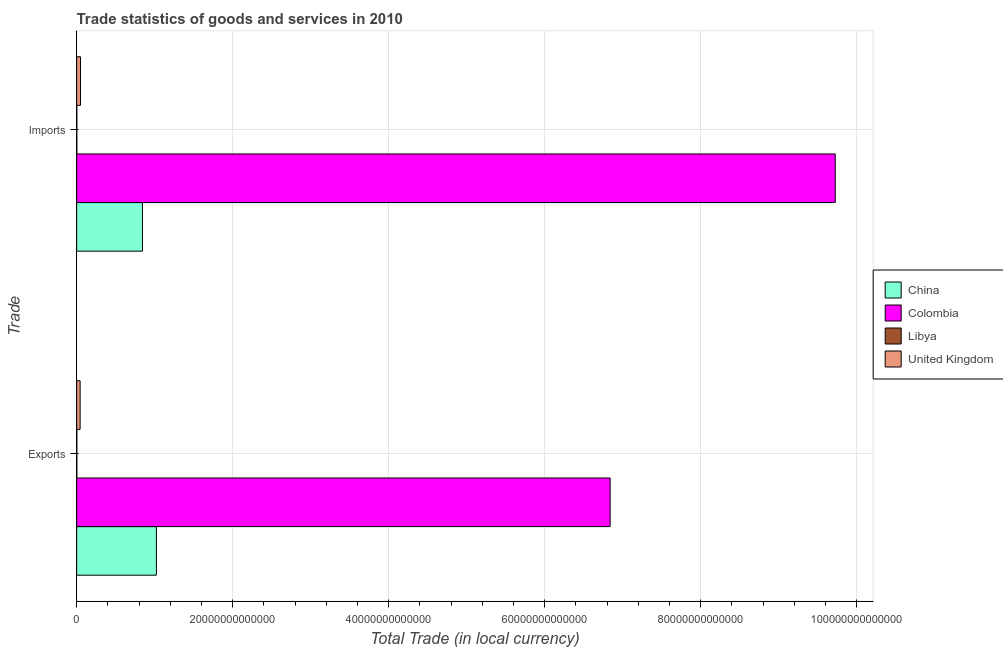How many groups of bars are there?
Offer a very short reply. 2. Are the number of bars on each tick of the Y-axis equal?
Ensure brevity in your answer.  Yes. How many bars are there on the 1st tick from the top?
Provide a short and direct response. 4. How many bars are there on the 1st tick from the bottom?
Provide a short and direct response. 4. What is the label of the 2nd group of bars from the top?
Your answer should be compact. Exports. What is the imports of goods and services in United Kingdom?
Offer a terse response. 4.87e+11. Across all countries, what is the maximum export of goods and services?
Give a very brief answer. 6.84e+13. Across all countries, what is the minimum imports of goods and services?
Provide a short and direct response. 1.88e+1. In which country was the imports of goods and services minimum?
Ensure brevity in your answer.  Libya. What is the total imports of goods and services in the graph?
Provide a succinct answer. 1.06e+14. What is the difference between the export of goods and services in China and that in Colombia?
Keep it short and to the point. -5.82e+13. What is the difference between the export of goods and services in United Kingdom and the imports of goods and services in Colombia?
Your answer should be very brief. -9.68e+13. What is the average imports of goods and services per country?
Your answer should be very brief. 2.66e+13. What is the difference between the export of goods and services and imports of goods and services in United Kingdom?
Provide a short and direct response. -4.30e+1. In how many countries, is the imports of goods and services greater than 16000000000000 LCU?
Keep it short and to the point. 1. What is the ratio of the export of goods and services in United Kingdom to that in Libya?
Give a very brief answer. 20.94. Is the export of goods and services in Colombia less than that in China?
Offer a very short reply. No. What does the 3rd bar from the bottom in Imports represents?
Your answer should be compact. Libya. How many bars are there?
Ensure brevity in your answer.  8. What is the difference between two consecutive major ticks on the X-axis?
Your answer should be very brief. 2.00e+13. Are the values on the major ticks of X-axis written in scientific E-notation?
Offer a terse response. No. Where does the legend appear in the graph?
Provide a short and direct response. Center right. How many legend labels are there?
Your answer should be compact. 4. What is the title of the graph?
Your response must be concise. Trade statistics of goods and services in 2010. What is the label or title of the X-axis?
Your answer should be compact. Total Trade (in local currency). What is the label or title of the Y-axis?
Your response must be concise. Trade. What is the Total Trade (in local currency) of China in Exports?
Your answer should be very brief. 1.02e+13. What is the Total Trade (in local currency) of Colombia in Exports?
Your answer should be very brief. 6.84e+13. What is the Total Trade (in local currency) of Libya in Exports?
Provide a succinct answer. 2.12e+1. What is the Total Trade (in local currency) of United Kingdom in Exports?
Keep it short and to the point. 4.44e+11. What is the Total Trade (in local currency) of China in Imports?
Keep it short and to the point. 8.44e+12. What is the Total Trade (in local currency) in Colombia in Imports?
Your answer should be compact. 9.73e+13. What is the Total Trade (in local currency) in Libya in Imports?
Provide a short and direct response. 1.88e+1. What is the Total Trade (in local currency) of United Kingdom in Imports?
Your answer should be compact. 4.87e+11. Across all Trade, what is the maximum Total Trade (in local currency) of China?
Your answer should be very brief. 1.02e+13. Across all Trade, what is the maximum Total Trade (in local currency) in Colombia?
Give a very brief answer. 9.73e+13. Across all Trade, what is the maximum Total Trade (in local currency) in Libya?
Offer a terse response. 2.12e+1. Across all Trade, what is the maximum Total Trade (in local currency) in United Kingdom?
Provide a short and direct response. 4.87e+11. Across all Trade, what is the minimum Total Trade (in local currency) in China?
Provide a short and direct response. 8.44e+12. Across all Trade, what is the minimum Total Trade (in local currency) of Colombia?
Give a very brief answer. 6.84e+13. Across all Trade, what is the minimum Total Trade (in local currency) of Libya?
Make the answer very short. 1.88e+1. Across all Trade, what is the minimum Total Trade (in local currency) in United Kingdom?
Give a very brief answer. 4.44e+11. What is the total Total Trade (in local currency) in China in the graph?
Make the answer very short. 1.87e+13. What is the total Total Trade (in local currency) of Colombia in the graph?
Offer a very short reply. 1.66e+14. What is the total Total Trade (in local currency) in Libya in the graph?
Provide a succinct answer. 4.00e+1. What is the total Total Trade (in local currency) of United Kingdom in the graph?
Your response must be concise. 9.32e+11. What is the difference between the Total Trade (in local currency) in China in Exports and that in Imports?
Your response must be concise. 1.79e+12. What is the difference between the Total Trade (in local currency) in Colombia in Exports and that in Imports?
Offer a very short reply. -2.89e+13. What is the difference between the Total Trade (in local currency) of Libya in Exports and that in Imports?
Offer a very short reply. 2.47e+09. What is the difference between the Total Trade (in local currency) in United Kingdom in Exports and that in Imports?
Your answer should be very brief. -4.30e+1. What is the difference between the Total Trade (in local currency) of China in Exports and the Total Trade (in local currency) of Colombia in Imports?
Give a very brief answer. -8.70e+13. What is the difference between the Total Trade (in local currency) of China in Exports and the Total Trade (in local currency) of Libya in Imports?
Make the answer very short. 1.02e+13. What is the difference between the Total Trade (in local currency) in China in Exports and the Total Trade (in local currency) in United Kingdom in Imports?
Your answer should be compact. 9.74e+12. What is the difference between the Total Trade (in local currency) in Colombia in Exports and the Total Trade (in local currency) in Libya in Imports?
Offer a terse response. 6.84e+13. What is the difference between the Total Trade (in local currency) of Colombia in Exports and the Total Trade (in local currency) of United Kingdom in Imports?
Give a very brief answer. 6.79e+13. What is the difference between the Total Trade (in local currency) of Libya in Exports and the Total Trade (in local currency) of United Kingdom in Imports?
Offer a very short reply. -4.66e+11. What is the average Total Trade (in local currency) of China per Trade?
Keep it short and to the point. 9.33e+12. What is the average Total Trade (in local currency) of Colombia per Trade?
Give a very brief answer. 8.28e+13. What is the average Total Trade (in local currency) in Libya per Trade?
Your answer should be compact. 2.00e+1. What is the average Total Trade (in local currency) of United Kingdom per Trade?
Your response must be concise. 4.66e+11. What is the difference between the Total Trade (in local currency) in China and Total Trade (in local currency) in Colombia in Exports?
Provide a succinct answer. -5.82e+13. What is the difference between the Total Trade (in local currency) of China and Total Trade (in local currency) of Libya in Exports?
Provide a succinct answer. 1.02e+13. What is the difference between the Total Trade (in local currency) of China and Total Trade (in local currency) of United Kingdom in Exports?
Offer a very short reply. 9.78e+12. What is the difference between the Total Trade (in local currency) in Colombia and Total Trade (in local currency) in Libya in Exports?
Offer a very short reply. 6.84e+13. What is the difference between the Total Trade (in local currency) in Colombia and Total Trade (in local currency) in United Kingdom in Exports?
Offer a terse response. 6.80e+13. What is the difference between the Total Trade (in local currency) of Libya and Total Trade (in local currency) of United Kingdom in Exports?
Your answer should be very brief. -4.23e+11. What is the difference between the Total Trade (in local currency) of China and Total Trade (in local currency) of Colombia in Imports?
Provide a succinct answer. -8.88e+13. What is the difference between the Total Trade (in local currency) in China and Total Trade (in local currency) in Libya in Imports?
Your response must be concise. 8.42e+12. What is the difference between the Total Trade (in local currency) in China and Total Trade (in local currency) in United Kingdom in Imports?
Provide a succinct answer. 7.95e+12. What is the difference between the Total Trade (in local currency) of Colombia and Total Trade (in local currency) of Libya in Imports?
Provide a short and direct response. 9.72e+13. What is the difference between the Total Trade (in local currency) of Colombia and Total Trade (in local currency) of United Kingdom in Imports?
Provide a succinct answer. 9.68e+13. What is the difference between the Total Trade (in local currency) in Libya and Total Trade (in local currency) in United Kingdom in Imports?
Offer a very short reply. -4.69e+11. What is the ratio of the Total Trade (in local currency) in China in Exports to that in Imports?
Keep it short and to the point. 1.21. What is the ratio of the Total Trade (in local currency) of Colombia in Exports to that in Imports?
Provide a succinct answer. 0.7. What is the ratio of the Total Trade (in local currency) of Libya in Exports to that in Imports?
Offer a very short reply. 1.13. What is the ratio of the Total Trade (in local currency) of United Kingdom in Exports to that in Imports?
Your answer should be compact. 0.91. What is the difference between the highest and the second highest Total Trade (in local currency) of China?
Your answer should be very brief. 1.79e+12. What is the difference between the highest and the second highest Total Trade (in local currency) in Colombia?
Give a very brief answer. 2.89e+13. What is the difference between the highest and the second highest Total Trade (in local currency) of Libya?
Offer a very short reply. 2.47e+09. What is the difference between the highest and the second highest Total Trade (in local currency) in United Kingdom?
Make the answer very short. 4.30e+1. What is the difference between the highest and the lowest Total Trade (in local currency) of China?
Offer a terse response. 1.79e+12. What is the difference between the highest and the lowest Total Trade (in local currency) in Colombia?
Offer a terse response. 2.89e+13. What is the difference between the highest and the lowest Total Trade (in local currency) in Libya?
Provide a succinct answer. 2.47e+09. What is the difference between the highest and the lowest Total Trade (in local currency) of United Kingdom?
Offer a very short reply. 4.30e+1. 